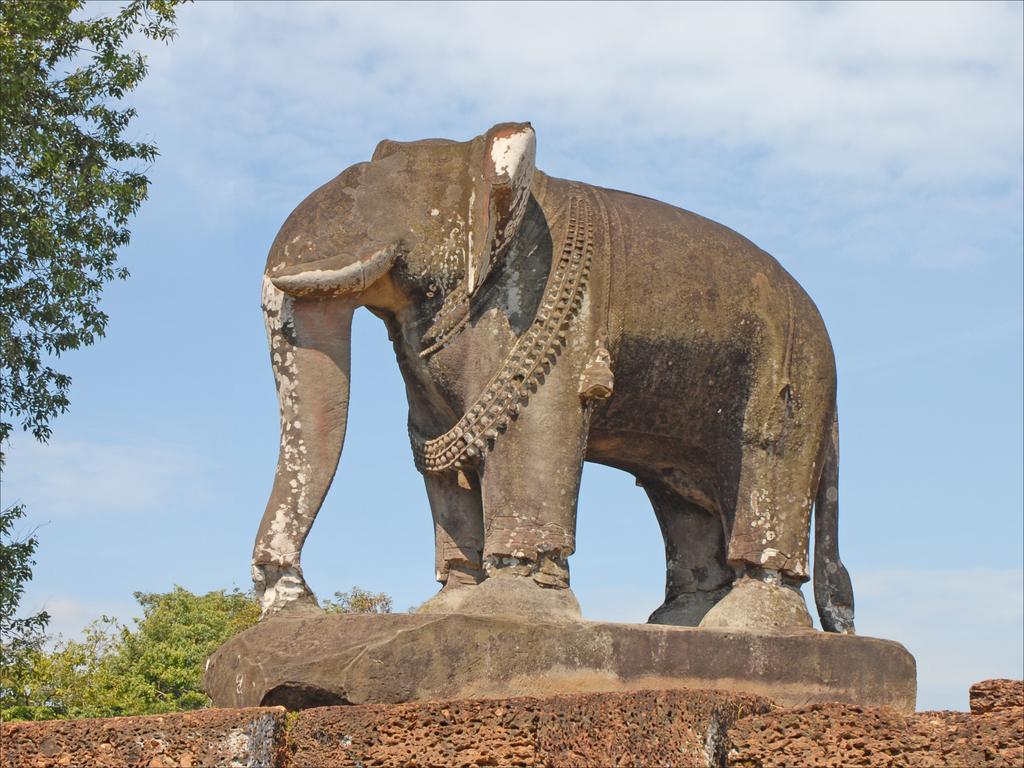Can you describe this image briefly? In this image, we can see a statue of an elephant. On the left side and background of the image, we can see trees and sky. 